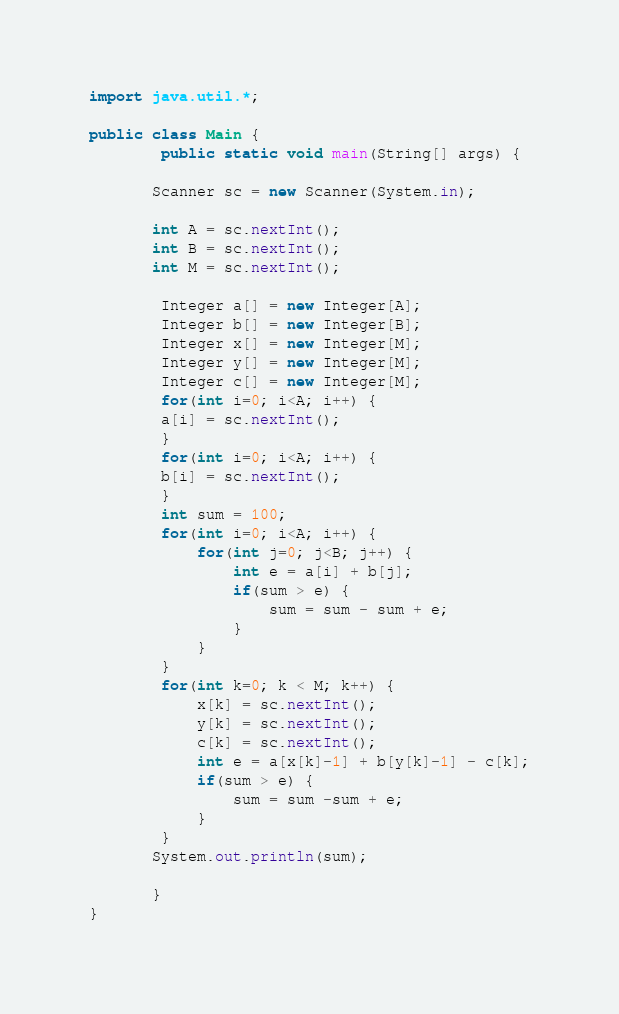<code> <loc_0><loc_0><loc_500><loc_500><_Java_>import java.util.*;

public class Main {
		public static void main(String[] args) {
		
	   Scanner sc = new Scanner(System.in);
	   
	   int A = sc.nextInt();
	   int B = sc.nextInt();
	   int M = sc.nextInt();
	   
		Integer a[] = new Integer[A];
		Integer b[] = new Integer[B];
		Integer x[] = new Integer[M];
		Integer y[] = new Integer[M];
		Integer c[] = new Integer[M];
		for(int i=0; i<A; i++) {
		a[i] = sc.nextInt();
		}
		for(int i=0; i<A; i++) {
		b[i] = sc.nextInt();
		}
		int sum = 100;
		for(int i=0; i<A; i++) {
			for(int j=0; j<B; j++) {
				int e = a[i] + b[j];
				if(sum > e) {
					sum = sum - sum + e;
				}
			}
		}
		for(int k=0; k < M; k++) {
			x[k] = sc.nextInt();
			y[k] = sc.nextInt();
			c[k] = sc.nextInt();
			int e = a[x[k]-1] + b[y[k]-1] - c[k];
			if(sum > e) {
				sum = sum -sum + e;
			}
		}
	   System.out.println(sum);
	   
	   }
}


</code> 